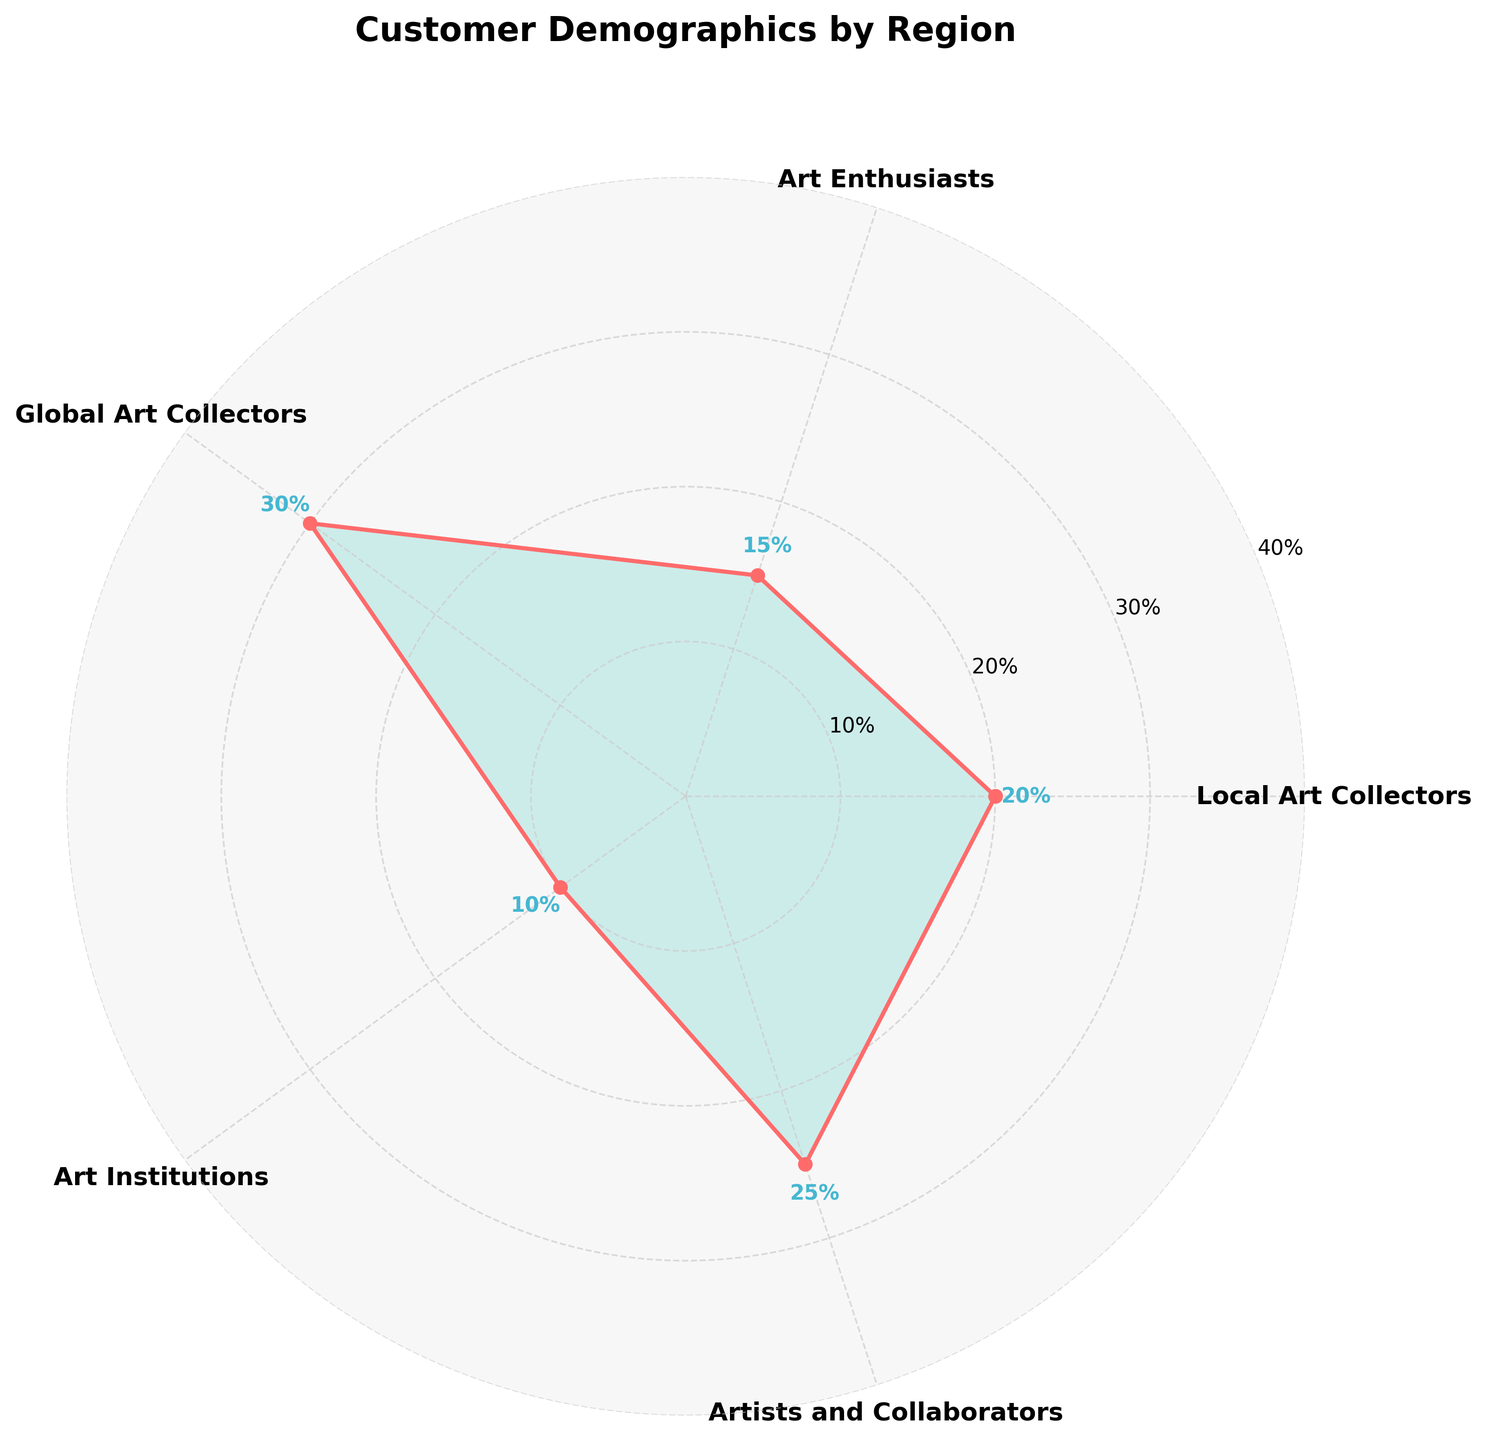What is the title of the chart? The title of the chart is usually placed at the top of the figure and can be read directly. Here, the title is clearly mentioned.
Answer: Customer Demographics by Region How many customer groups are represented in the chart? By counting the labeled axes around the rose chart, we find that there are six distinct customer groups.
Answer: 6 Which customer group has the highest percentage? By looking at the value labels on each axis, the 'Global Art Collectors' group has the highest percentage of 30%.
Answer: Global Art Collectors How does the percentage of 'Local Art Collectors' compare to 'Art Enthusiasts'? 'Local Art Collectors' have 20% while 'Art Enthusiasts' have 15%. Comparing these values shows 'Local Art Collectors' have a higher percentage.
Answer: Domestic - Local Art Collectors Calculate the average percentage of the groups under 'Domestic' region. The 'Domestic' region includes 'Local Art Collectors' (20%) and 'Art Enthusiasts' (15%). The average is calculated as (20 + 15) / 2 = 17.5%.
Answer: 17.5% Identify the region with the lowest percentage and name the customer group within it. By examining the values, 'Art Institutions' under 'International' region has the lowest percentage at 10%.
Answer: International - Art Institutions What percentage is assigned to the 'Artists and Collaborators' group? The value label on the axis for 'Artists and Collaborators' shows it has a 25% share.
Answer: 25% Which region contains the most diverse customer demographics in terms of group count? By counting the number of customer groups for each region: Domestic and International have 2 groups each, Local has 1 group. Both Domestic and International have more diversity.
Answer: Domestic and International Sum the percentages for all customer groups in the 'Domestic' and 'Local' regions. For 'Domestic': 20% and 15% (20 + 15 = 35%). For 'Local': 25%.
Answer: 35% and 25% Compare the total percentages of 'Local' and 'International' regions. 'Local' has a total of 25%, while 'International' has contributions from 'Global Art Collectors' (30%) and 'Art Institutions' (10%), summing to 40% (30 + 10). 'International' has a higher total.
Answer: Local: 25%, International: 40% 